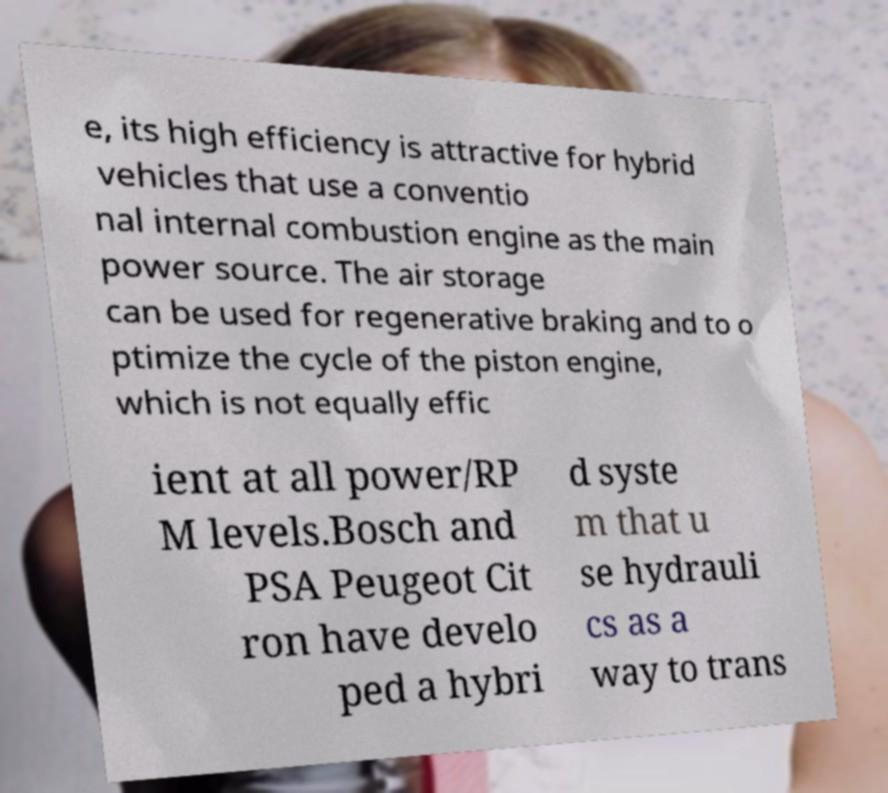Can you accurately transcribe the text from the provided image for me? e, its high efficiency is attractive for hybrid vehicles that use a conventio nal internal combustion engine as the main power source. The air storage can be used for regenerative braking and to o ptimize the cycle of the piston engine, which is not equally effic ient at all power/RP M levels.Bosch and PSA Peugeot Cit ron have develo ped a hybri d syste m that u se hydrauli cs as a way to trans 